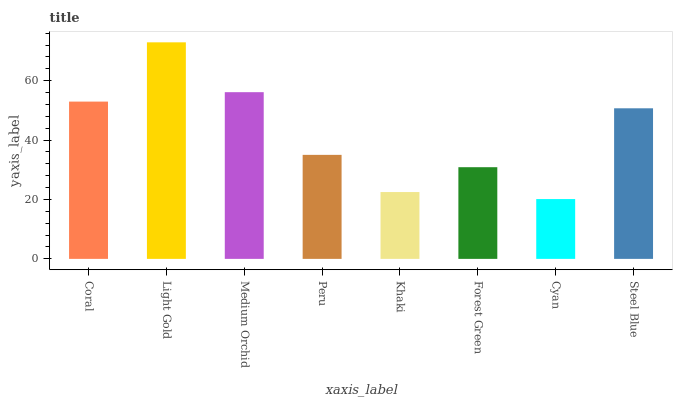Is Medium Orchid the minimum?
Answer yes or no. No. Is Medium Orchid the maximum?
Answer yes or no. No. Is Light Gold greater than Medium Orchid?
Answer yes or no. Yes. Is Medium Orchid less than Light Gold?
Answer yes or no. Yes. Is Medium Orchid greater than Light Gold?
Answer yes or no. No. Is Light Gold less than Medium Orchid?
Answer yes or no. No. Is Steel Blue the high median?
Answer yes or no. Yes. Is Peru the low median?
Answer yes or no. Yes. Is Khaki the high median?
Answer yes or no. No. Is Forest Green the low median?
Answer yes or no. No. 